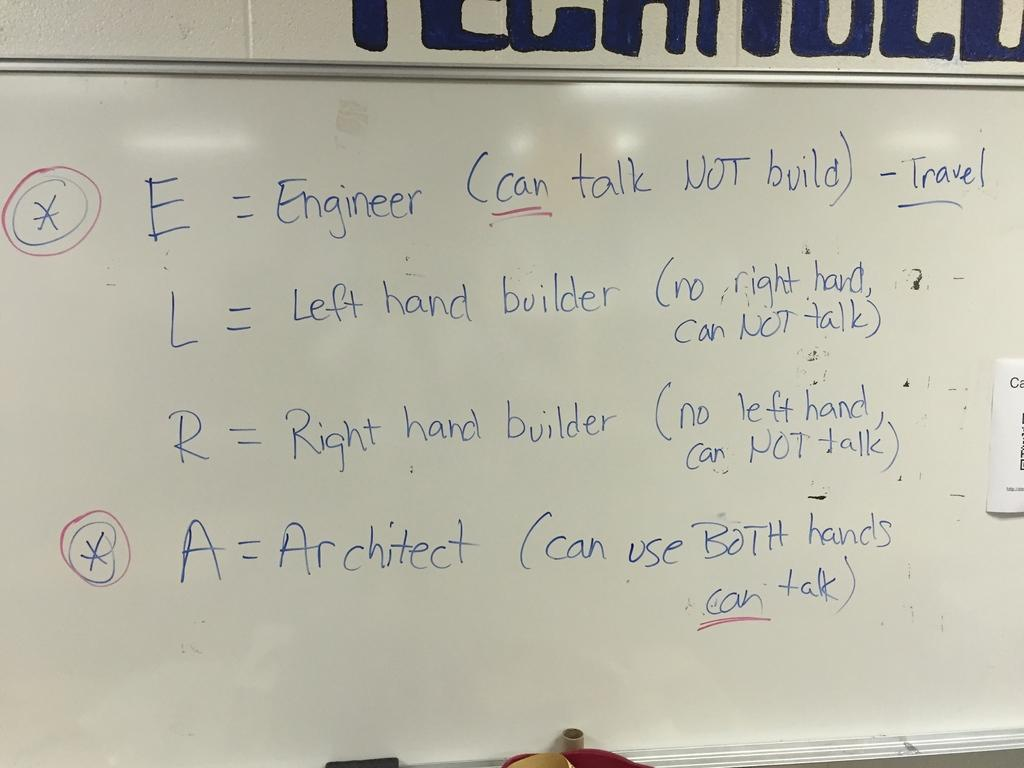<image>
Give a short and clear explanation of the subsequent image. the word engineer is on the white board 